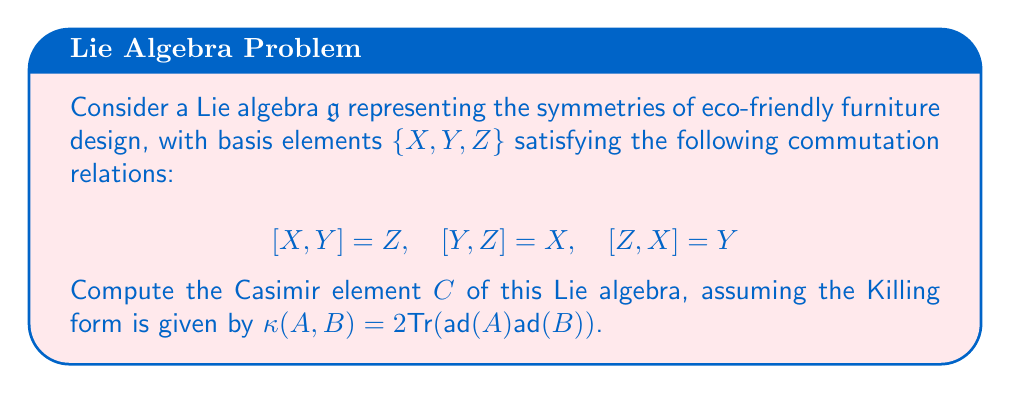What is the answer to this math problem? To compute the Casimir element, we'll follow these steps:

1) First, we need to calculate the Killing form matrix. For each pair of basis elements, we compute:

   $\kappa(X, X) = \kappa(Y, Y) = \kappa(Z, Z) = 4$
   $\kappa(X, Y) = \kappa(Y, Z) = \kappa(Z, X) = 0$

   The Killing form matrix is thus:
   $$K = \begin{pmatrix}
   4 & 0 & 0 \\
   0 & 4 & 0 \\
   0 & 0 & 4
   \end{pmatrix}$$

2) The inverse of this matrix is:
   $$K^{-1} = \begin{pmatrix}
   1/4 & 0 & 0 \\
   0 & 1/4 & 0 \\
   0 & 0 & 1/4
   \end{pmatrix}$$

3) The Casimir element is given by:
   $$C = \sum_{i,j} K^{ij} X_i X_j$$
   where $K^{ij}$ are the elements of the inverse Killing form matrix, and $X_i$ are the basis elements.

4) Substituting the values:
   $$C = \frac{1}{4}X^2 + \frac{1}{4}Y^2 + \frac{1}{4}Z^2$$

5) Therefore, the Casimir element can be written as:
   $$C = \frac{1}{4}(X^2 + Y^2 + Z^2)$$

This Casimir element represents a quadratic invariant of the Lie algebra, which could be interpreted in the context of eco-friendly furniture design as a measure of the overall symmetry or balance in the design process.
Answer: $$C = \frac{1}{4}(X^2 + Y^2 + Z^2)$$ 